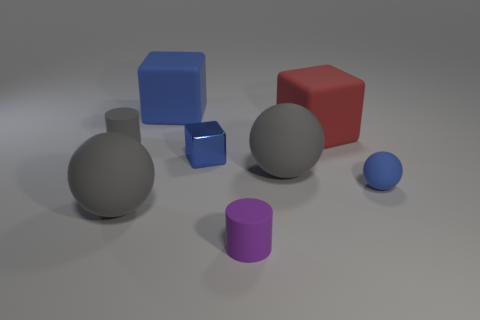Are there any other things of the same color as the small matte sphere?
Keep it short and to the point. Yes. Are there more purple rubber things than yellow matte objects?
Offer a very short reply. Yes. Is the material of the tiny blue ball the same as the small purple thing?
Your answer should be compact. Yes. How many red blocks are made of the same material as the small gray cylinder?
Offer a terse response. 1. There is a metallic block; does it have the same size as the gray thing on the right side of the blue metallic block?
Your answer should be very brief. No. What is the color of the object that is both on the right side of the shiny object and in front of the small blue rubber sphere?
Make the answer very short. Purple. Are there an equal number of gray matte things and large purple rubber spheres?
Your answer should be very brief. No. Is there a blue thing that is on the right side of the blue ball that is on the right side of the tiny gray cylinder?
Keep it short and to the point. No. Is the number of tiny blue metal objects behind the tiny blue sphere the same as the number of large blue metallic things?
Give a very brief answer. No. How many gray things are in front of the big gray object to the right of the blue cube that is behind the gray rubber cylinder?
Offer a terse response. 1. 